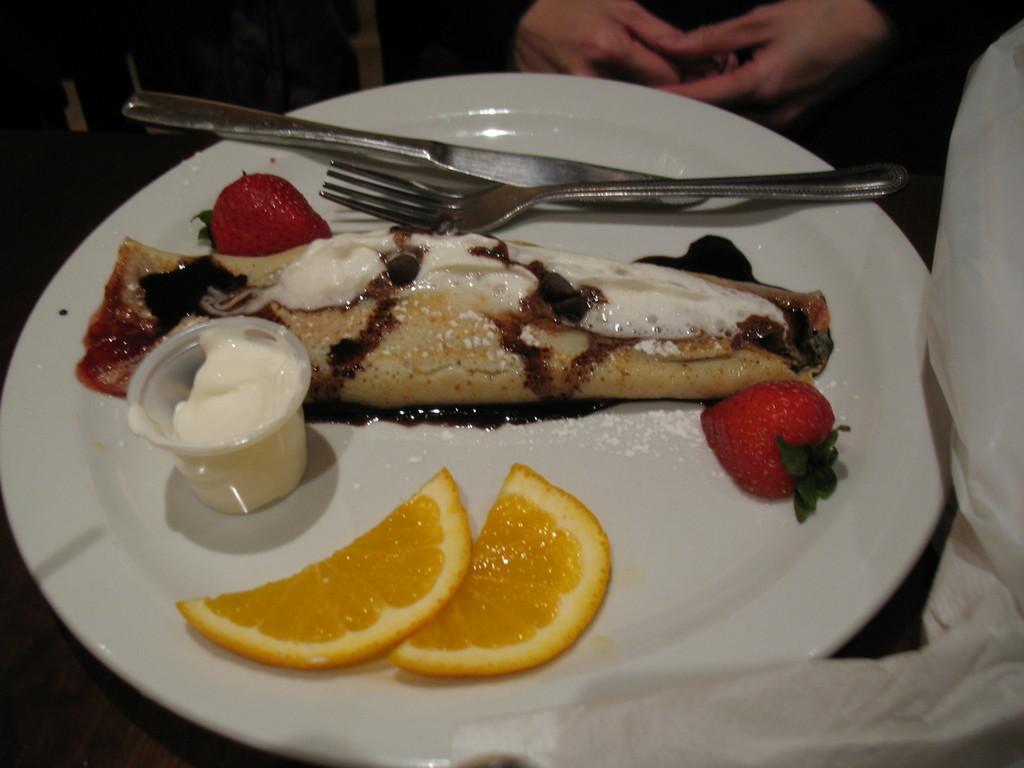What is on the plate that is visible in the image? The plate contains strawberries, lemons, and cream. What utensils are on the plate? There is a fork and a knife on the plate. Who is visible in the image? There is a person visible in the image. What type of bone is being held by the person in the image? There is no bone visible in the image; the person is not holding anything. 